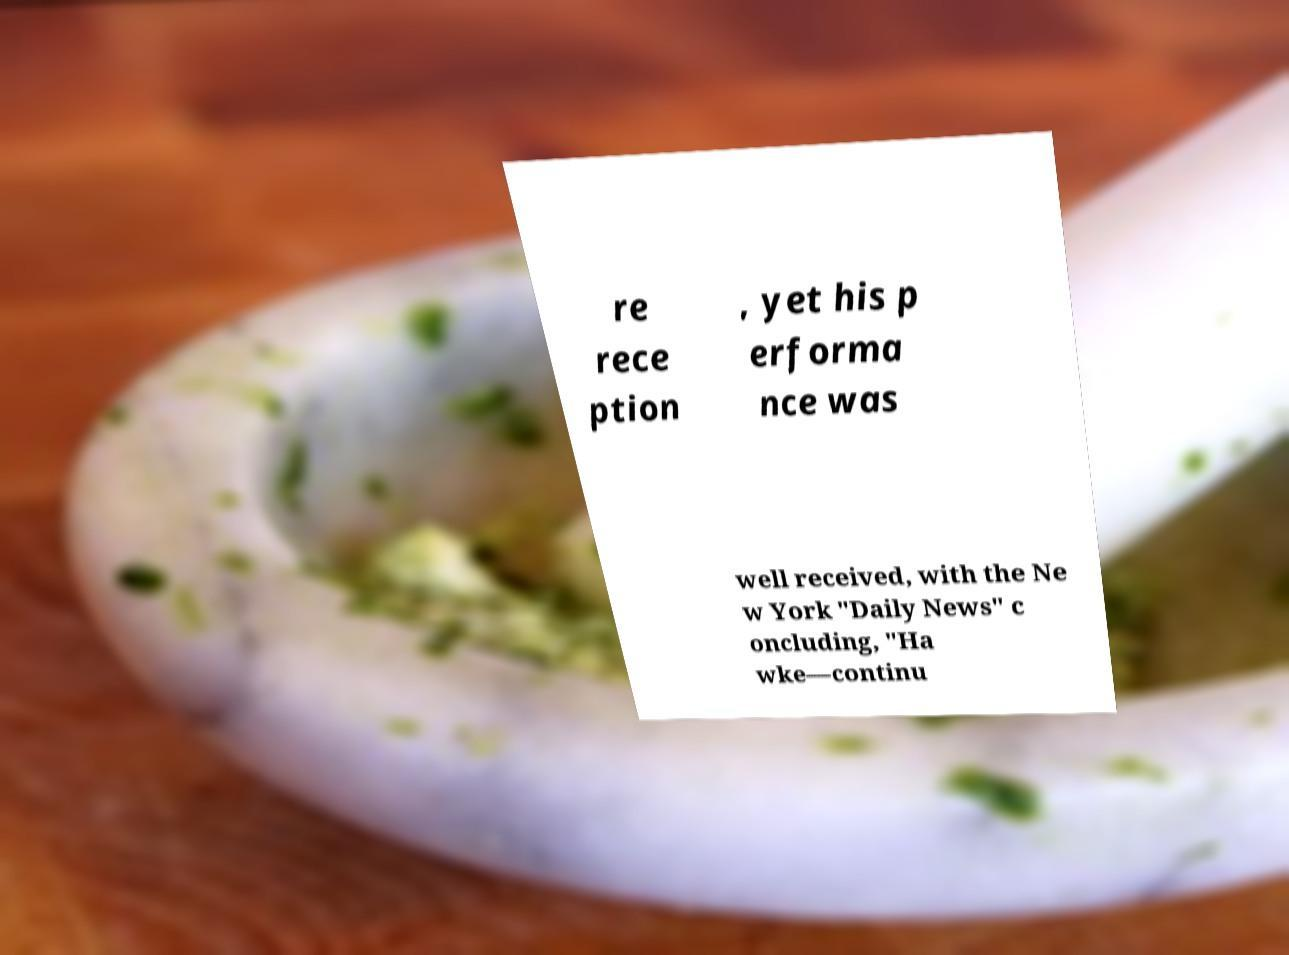I need the written content from this picture converted into text. Can you do that? re rece ption , yet his p erforma nce was well received, with the Ne w York "Daily News" c oncluding, "Ha wke—continu 